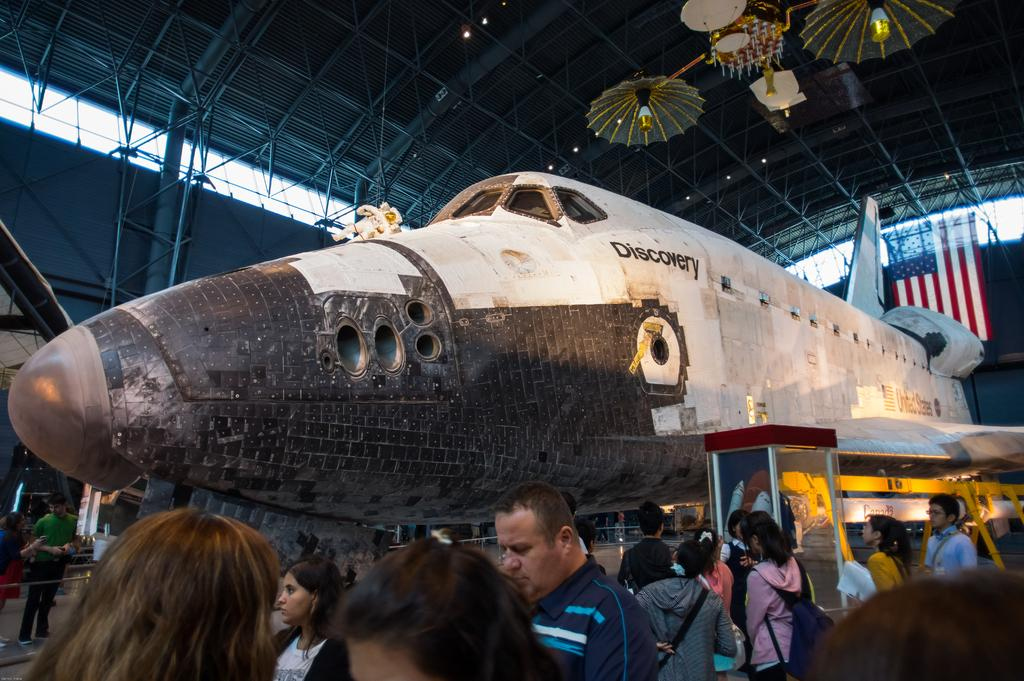What is being constructed in the image? There is an aeroplane under construction in the image. Who is observing the construction process? A group of people are looking at the aeroplane. What type of roof is visible in the image? There is an iron roof visible in the image. What type of treatment is being administered to the aeroplane in the image? There is no treatment being administered to the aeroplane in the image; it is under construction. What kind of lumber is being used to build the aeroplane in the image? The facts provided do not mention any lumber being used in the construction of the aeroplane. 